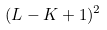Convert formula to latex. <formula><loc_0><loc_0><loc_500><loc_500>( L - K + 1 ) ^ { 2 }</formula> 